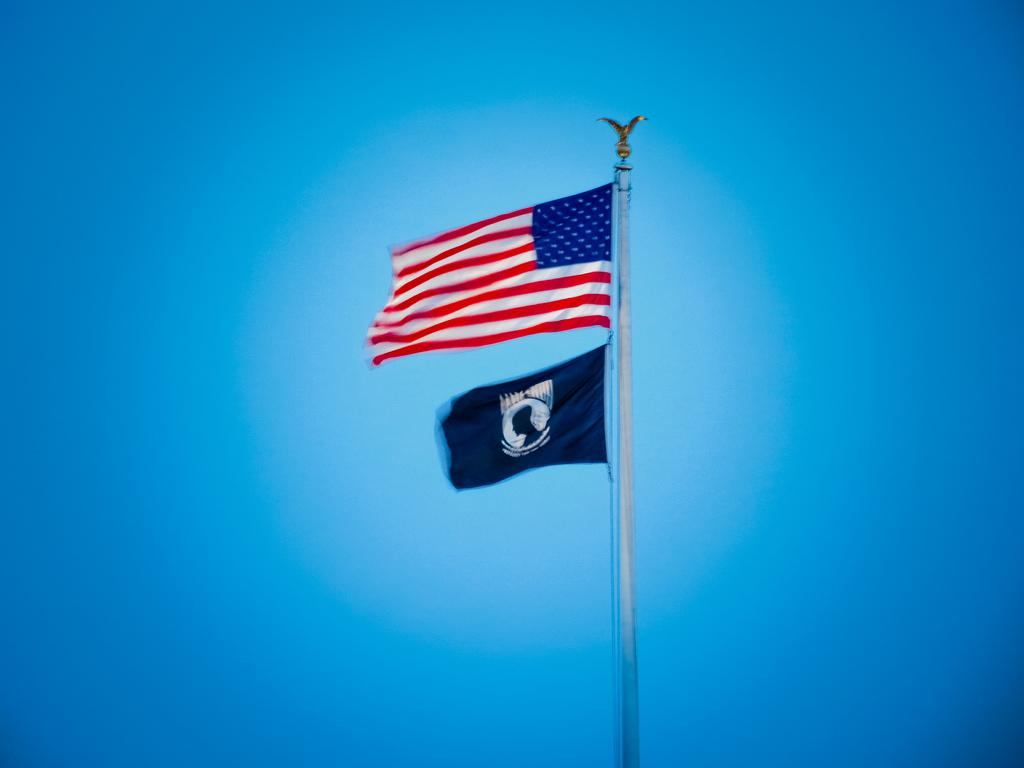What is the main subject of the image? The main subject of the image is flags. Where are the flags located in the image? The flags are in the center of the image. What type of ring can be seen on the flag in the image? There is no ring present on the flag in the image. 